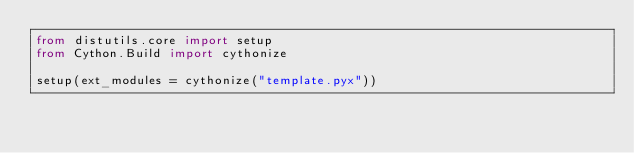<code> <loc_0><loc_0><loc_500><loc_500><_Python_>from distutils.core import setup
from Cython.Build import cythonize

setup(ext_modules = cythonize("template.pyx"))</code> 